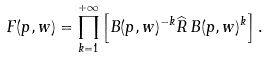<formula> <loc_0><loc_0><loc_500><loc_500>F ( p , w ) = \prod _ { k = 1 } ^ { + \infty } \left [ B ( p , w ) ^ { - k } \widehat { R } \, B ( p , w ) ^ { k } \right ] .</formula> 